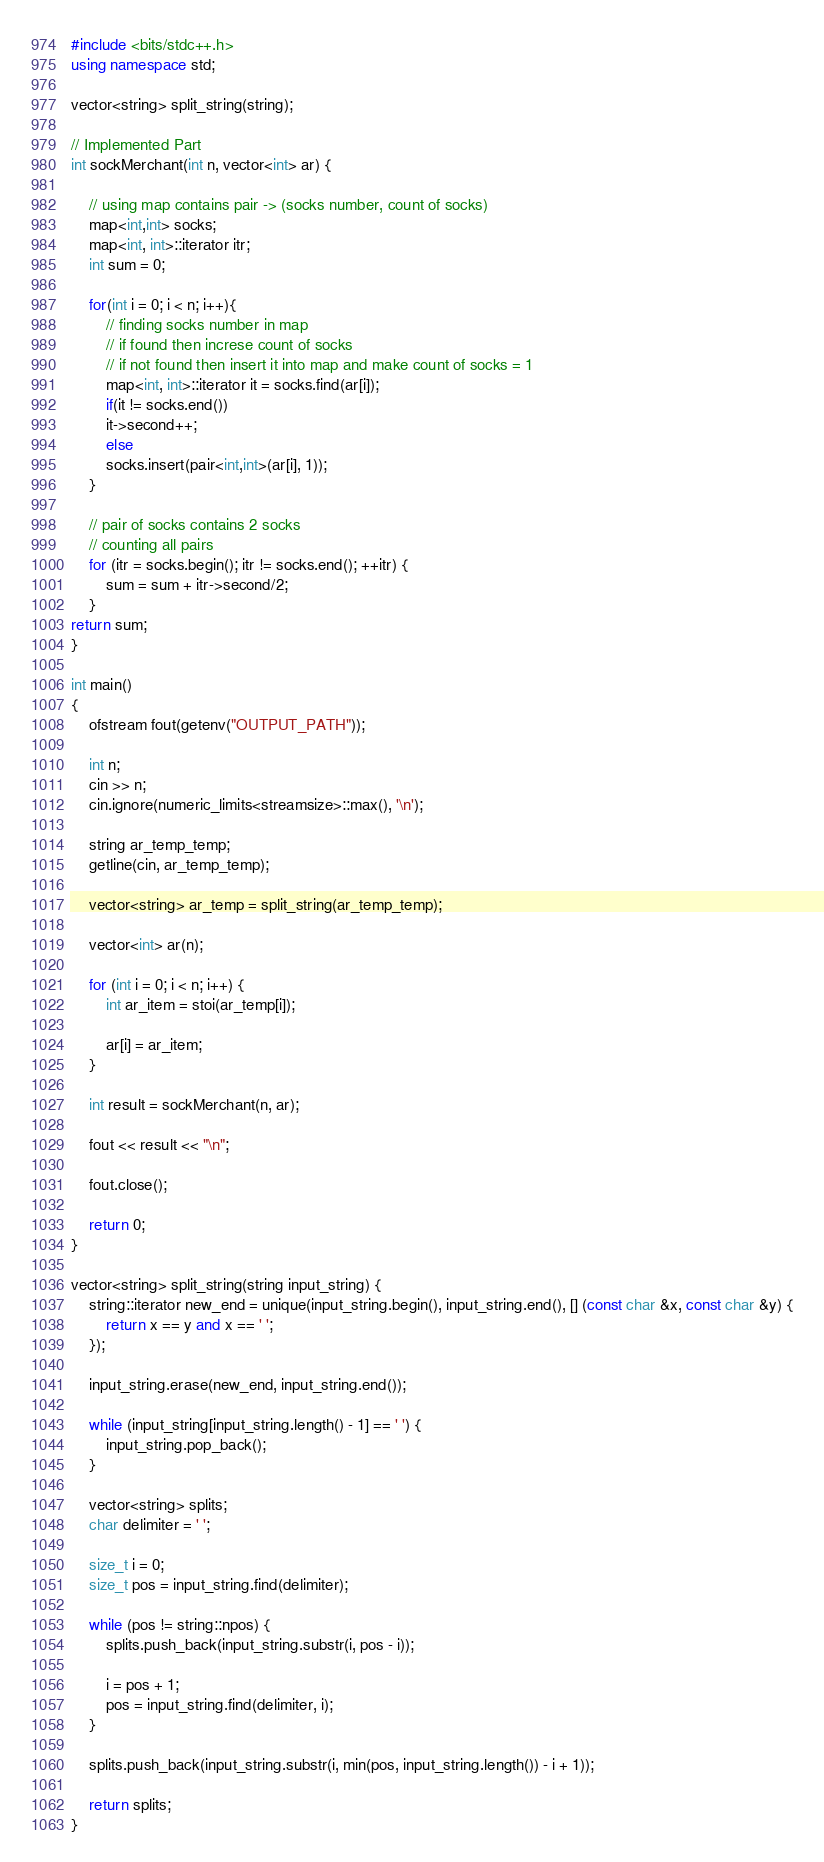Convert code to text. <code><loc_0><loc_0><loc_500><loc_500><_C++_>#include <bits/stdc++.h>
using namespace std;

vector<string> split_string(string);

// Implemented Part
int sockMerchant(int n, vector<int> ar) {
    
    // using map contains pair -> (socks number, count of socks)
    map<int,int> socks;
    map<int, int>::iterator itr; 
    int sum = 0;
    
    for(int i = 0; i < n; i++){
        // finding socks number in map
        // if found then increse count of socks
        // if not found then insert it into map and make count of socks = 1
        map<int, int>::iterator it = socks.find(ar[i]); 
        if(it != socks.end())
        it->second++;
        else
        socks.insert(pair<int,int>(ar[i], 1));
    } 

    // pair of socks contains 2 socks
    // counting all pairs
    for (itr = socks.begin(); itr != socks.end(); ++itr) { 
        sum = sum + itr->second/2;
    }     
return sum;
}

int main()
{
    ofstream fout(getenv("OUTPUT_PATH"));

    int n;
    cin >> n;
    cin.ignore(numeric_limits<streamsize>::max(), '\n');

    string ar_temp_temp;
    getline(cin, ar_temp_temp);

    vector<string> ar_temp = split_string(ar_temp_temp);

    vector<int> ar(n);

    for (int i = 0; i < n; i++) {
        int ar_item = stoi(ar_temp[i]);

        ar[i] = ar_item;
    }

    int result = sockMerchant(n, ar);

    fout << result << "\n";

    fout.close();

    return 0;
}

vector<string> split_string(string input_string) {
    string::iterator new_end = unique(input_string.begin(), input_string.end(), [] (const char &x, const char &y) {
        return x == y and x == ' ';
    });

    input_string.erase(new_end, input_string.end());

    while (input_string[input_string.length() - 1] == ' ') {
        input_string.pop_back();
    }

    vector<string> splits;
    char delimiter = ' ';

    size_t i = 0;
    size_t pos = input_string.find(delimiter);

    while (pos != string::npos) {
        splits.push_back(input_string.substr(i, pos - i));

        i = pos + 1;
        pos = input_string.find(delimiter, i);
    }

    splits.push_back(input_string.substr(i, min(pos, input_string.length()) - i + 1));

    return splits;
}

</code> 